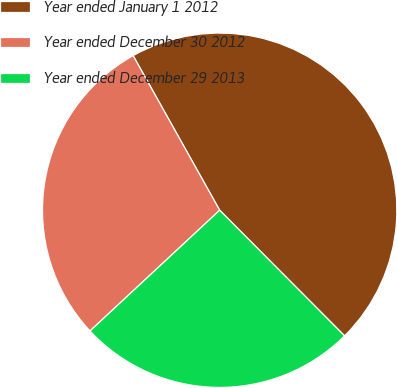<chart> <loc_0><loc_0><loc_500><loc_500><pie_chart><fcel>Year ended January 1 2012<fcel>Year ended December 30 2012<fcel>Year ended December 29 2013<nl><fcel>45.67%<fcel>28.81%<fcel>25.52%<nl></chart> 